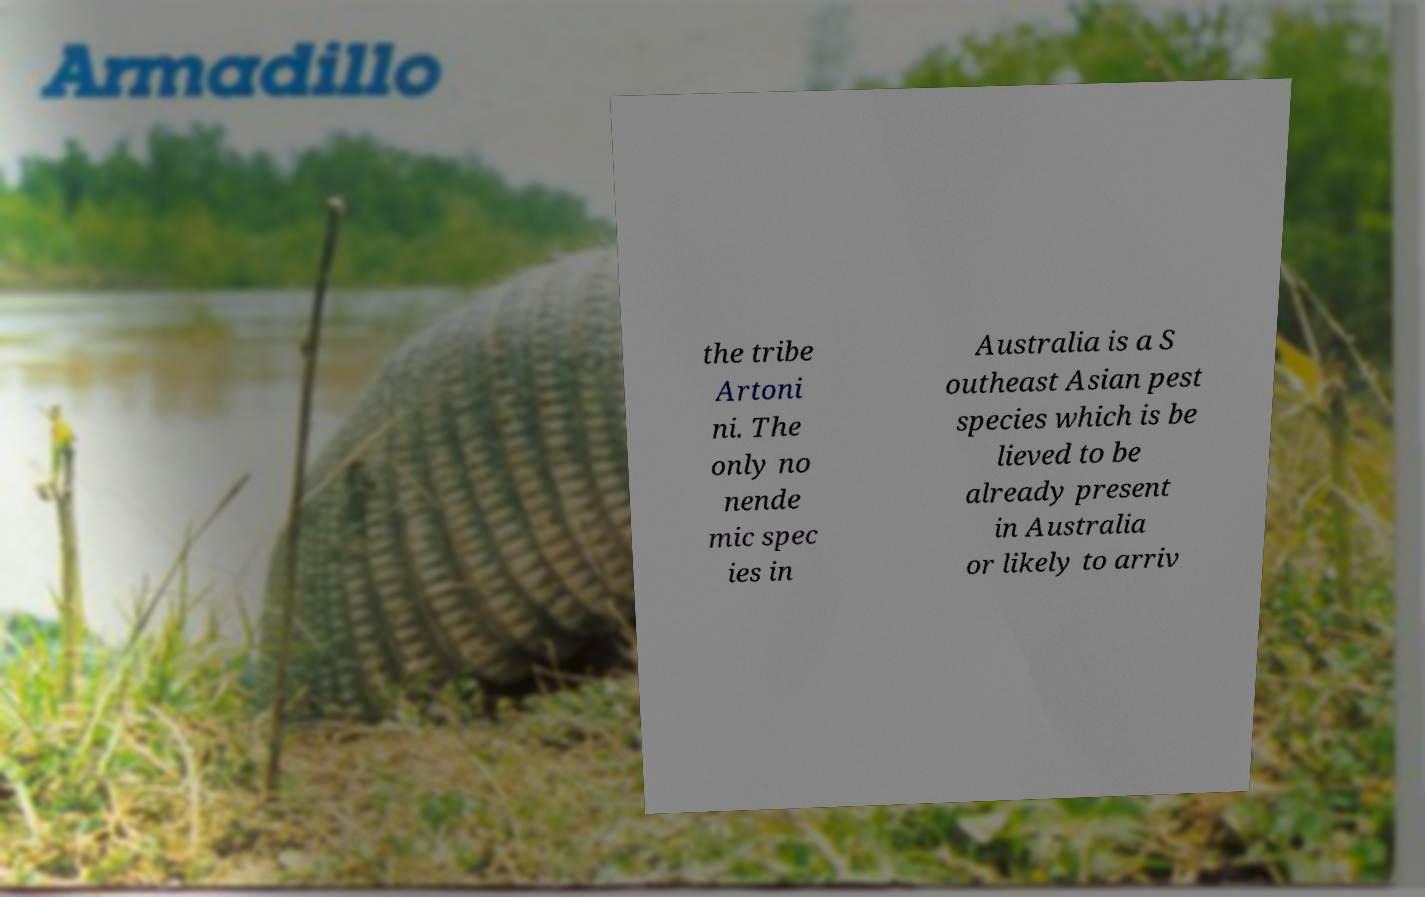There's text embedded in this image that I need extracted. Can you transcribe it verbatim? the tribe Artoni ni. The only no nende mic spec ies in Australia is a S outheast Asian pest species which is be lieved to be already present in Australia or likely to arriv 